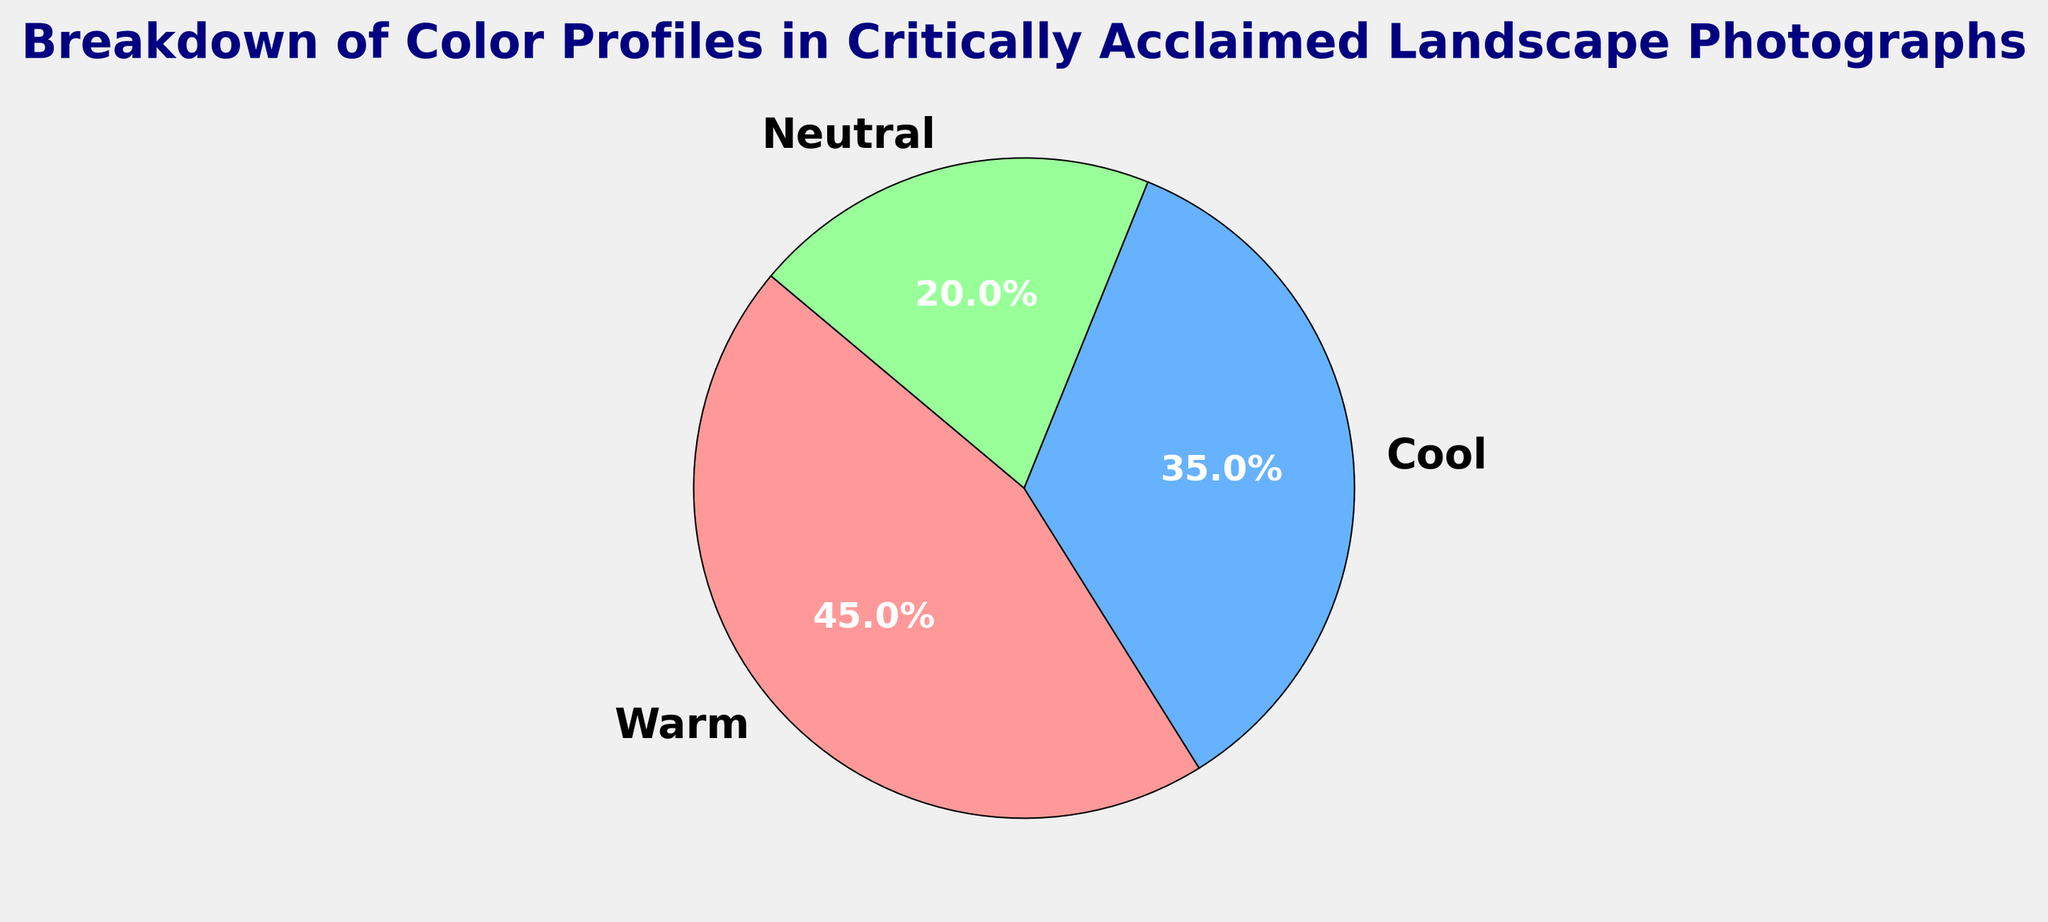What is the percentage of photographs with a warm color profile? The figure shows a pie chart with three color profiles: warm, cool, and neutral. To find the percentage of photographs with a warm color profile, simply refer to the section labeled "Warm" in the pie chart.
Answer: 45% What is the total percentage of landscape photographs with either warm or cool color profiles? To determine the total percentage of photographs with warm or cool color profiles, add the percentage of warm color profiles (45%) to the percentage of cool color profiles (35%). Therefore, 45% + 35% = 80%.
Answer: 80% Between the cool and neutral color profiles, which one is used more frequently in landscape photographs? Compare the percentages of the cool and neutral color profiles. The cool profile has 35%, whereas the neutral profile has 20%. Since 35% is greater than 20%, the cool color profile is used more frequently.
Answer: Cool What is the difference in the percentages between the warm and neutral color profiles? To find the difference between the warm and neutral color profiles, subtract the percentage of the neutral profile (20%) from the warm profile (45%). Therefore, 45% - 20% = 25%.
Answer: 25% If you combine the percentage of neutral and cool color profiles, does it exceed the percentage of the warm color profile? Add the percentages of the neutral and cool color profiles and compare the sum to the warm color profile. The neutral profile is 20% and the cool profile is 35%. Combined, they are 20% + 35% = 55%. Since 55% is greater than the warm profile's 45%, the combined percentage exceeds the warm profile percentage.
Answer: Yes Which color profile occupies the smallest portion of the pie chart? Identify the section of the pie chart with the smallest percentage. The segments are 45% (warm), 35% (cool), and 20% (neutral). The neutral profile, with 20%, is the smallest.
Answer: Neutral What is the visual color associated with the cool color profile in the pie chart? The pie chart visually displays color profiles in specific colors. The cool color profile is colored in shades of blue.
Answer: Blue 